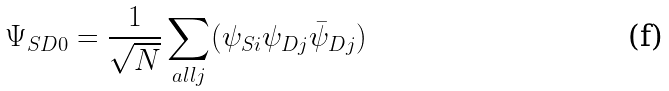Convert formula to latex. <formula><loc_0><loc_0><loc_500><loc_500>\Psi _ { S D 0 } = \frac { 1 } { \sqrt { N } } \sum _ { a l l j } ( \psi _ { S i } \psi _ { D j } \bar { \psi } _ { D j } )</formula> 